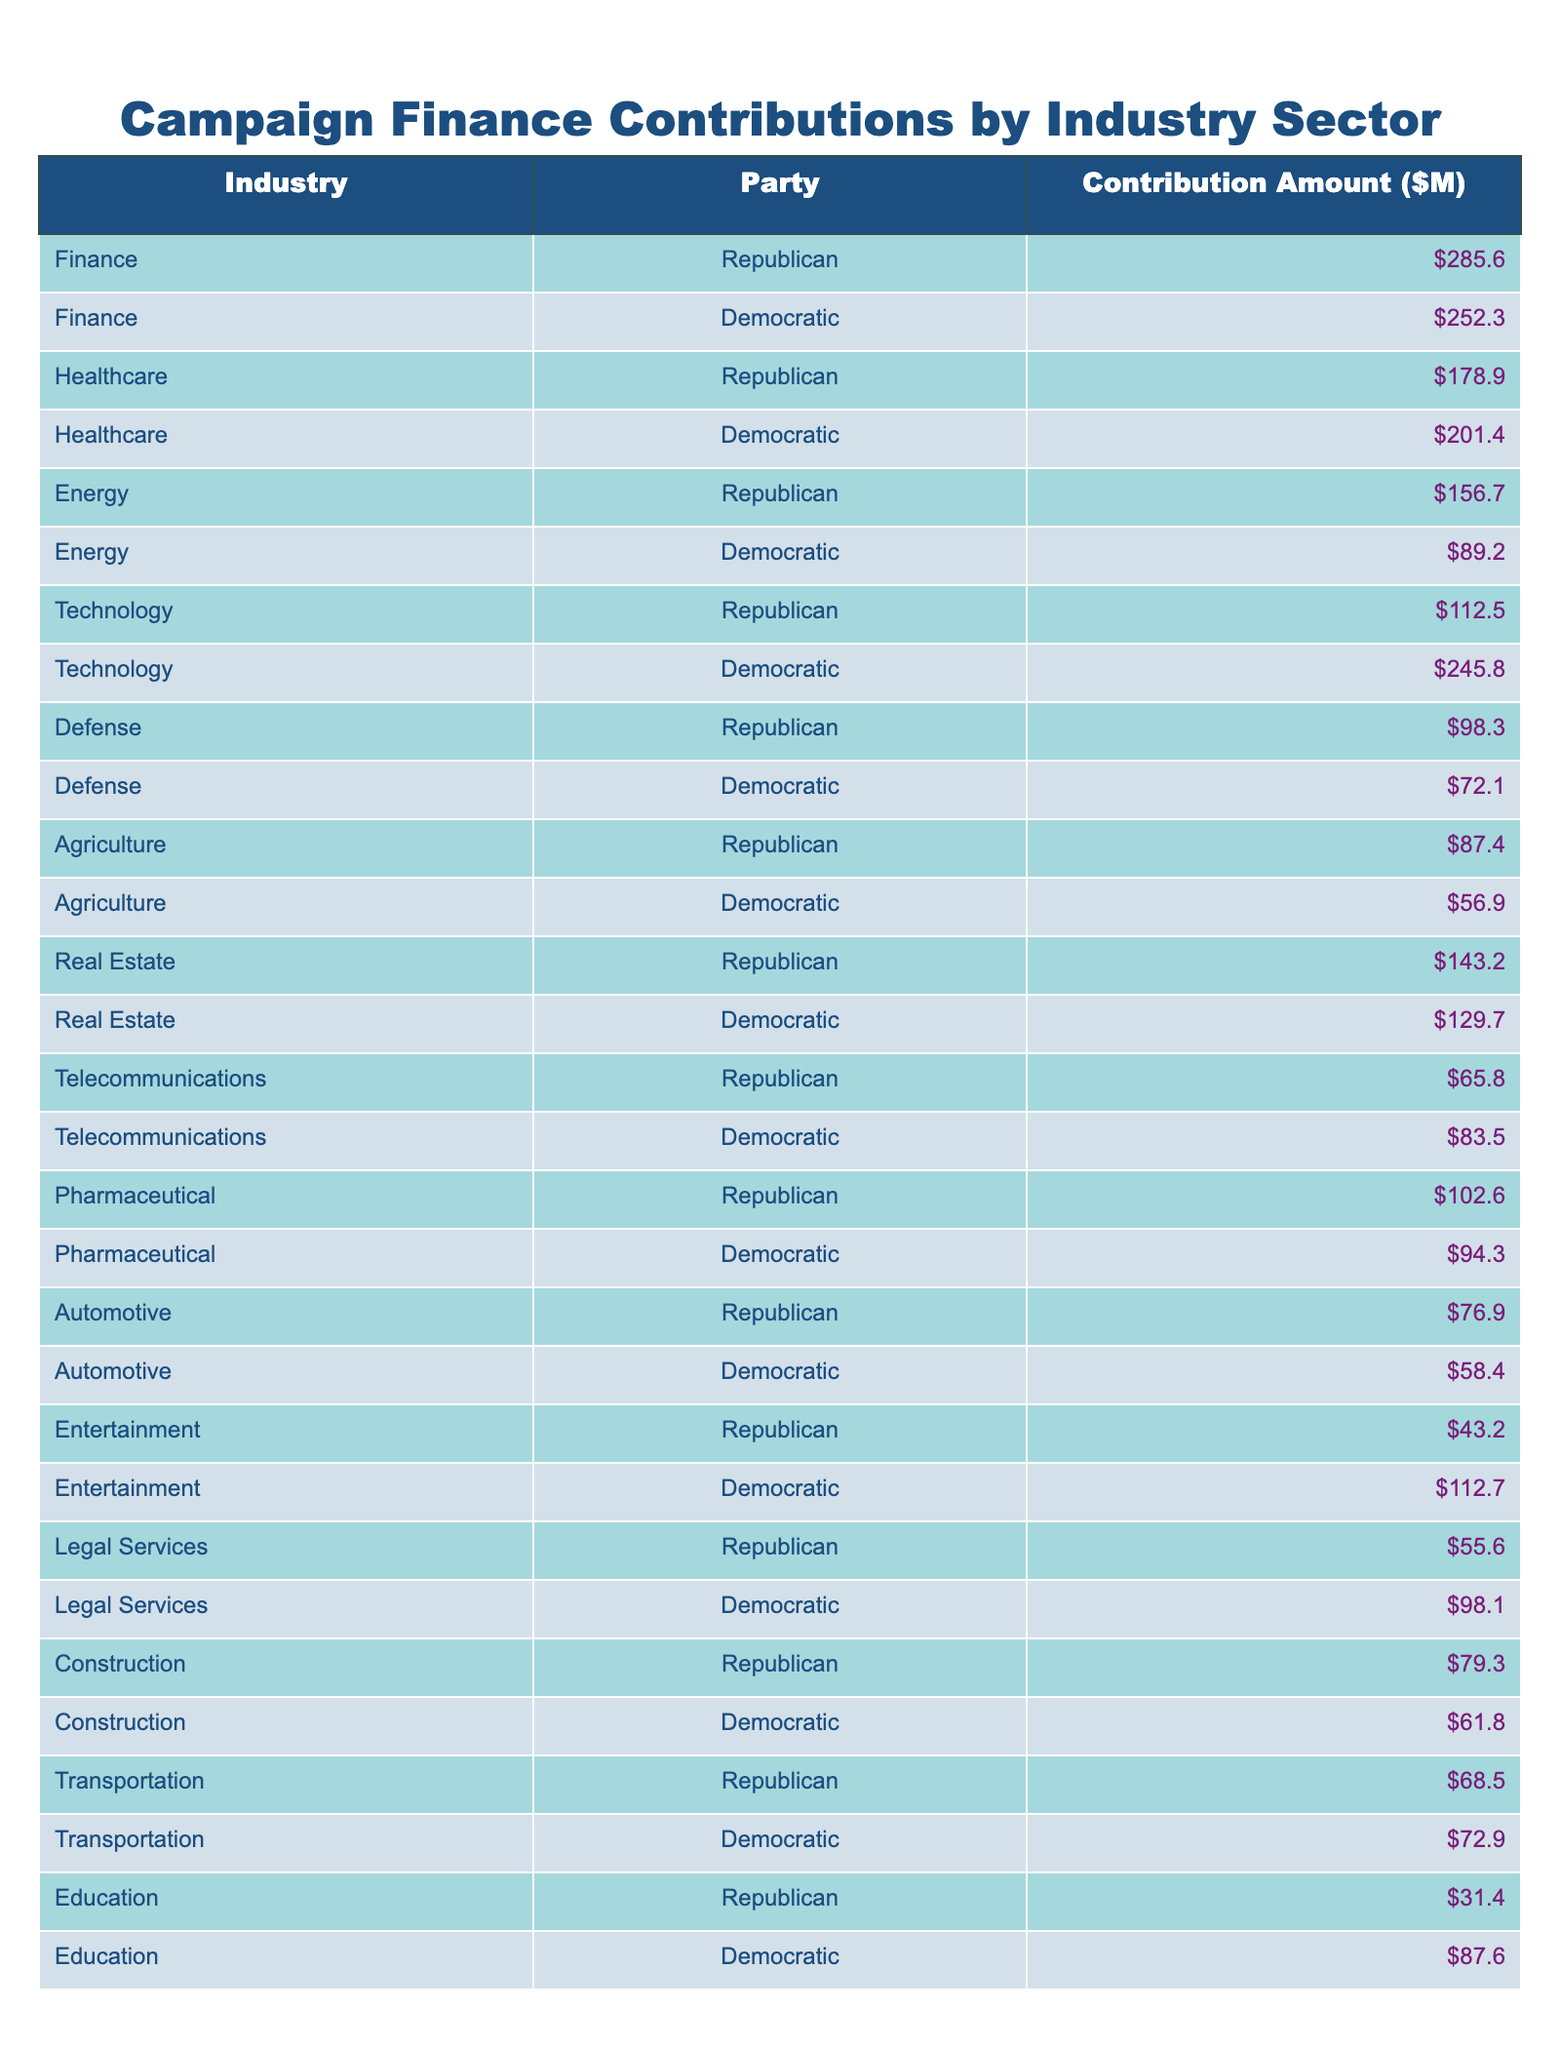What is the total contribution amount from the Finance sector to the Republican Party? The table shows that the contribution amount from the Finance sector to the Republican Party is listed as 285.6 million dollars.
Answer: 285.6 million Which party received more contributions from the Technology sector? The table indicates that the Democratic Party received 245.8 million while the Republican Party received 112.5 million from the Technology sector. Thus, the Democratic Party received more.
Answer: Democratic Party What is the difference in contributions from the Healthcare sector between the two parties? The Republican Party received 178.9 million, and the Democratic Party received 201.4 million. The difference is calculated as 201.4 - 178.9 = 22.5 million.
Answer: 22.5 million Which sector contributed more to the Republican Party: Agriculture or Telecommunications? The Agricultural sector contributed 87.4 million, while the Telecommunications sector contributed 65.8 million to the Republican Party. Since 87.4 million is greater than 65.8 million, Agriculture contributed more.
Answer: Agriculture What is the average contribution amount from the Defense sector across both parties? The Republican Party received 98.3 million and the Democratic Party received 72.1 million. To find the average, we sum these contributions: 98.3 + 72.1 = 170.4 million, then divide by 2. Thus, the average is 170.4 / 2 = 85.2 million.
Answer: 85.2 million Which party received the least contributions from the Automotive sector? In the Automotive sector, the Republican Party received 76.9 million and the Democratic Party received 58.4 million. Since 58.4 million is less than 76.9 million, the Democratic Party received the least.
Answer: Democratic Party Considering all sectors, which political party received the highest total contributions? By reviewing the sums of all contributions for each party, the Republican Party received a total of 1,042.2 million, while the Democratic Party received 1,096.9 million. Thus, the Democratic Party received the highest total contributions.
Answer: Democratic Party Is the contribution from the Entertainment sector to the Republican Party higher than that to the Democratic Party? The Republican Party received 43.2 million from the Entertainment sector, while the Democratic Party received 112.7 million. Since 112.7 million is greater than 43.2 million, the Republican Party did not receive more.
Answer: No What is the total contribution amount from the Healthcare and Pharmaceutical sectors combined for the Democratic Party? The Democratic Party received 201.4 million from Healthcare and 94.3 million from Pharmaceuticals. To find the combined total, we calculate 201.4 + 94.3 = 295.7 million.
Answer: 295.7 million Which industry sector had the lowest contributions to the Republican Party? Upon reviewing the contributions, the sector that had the lowest contribution to the Republican Party is Education, which received 31.4 million.
Answer: Education 